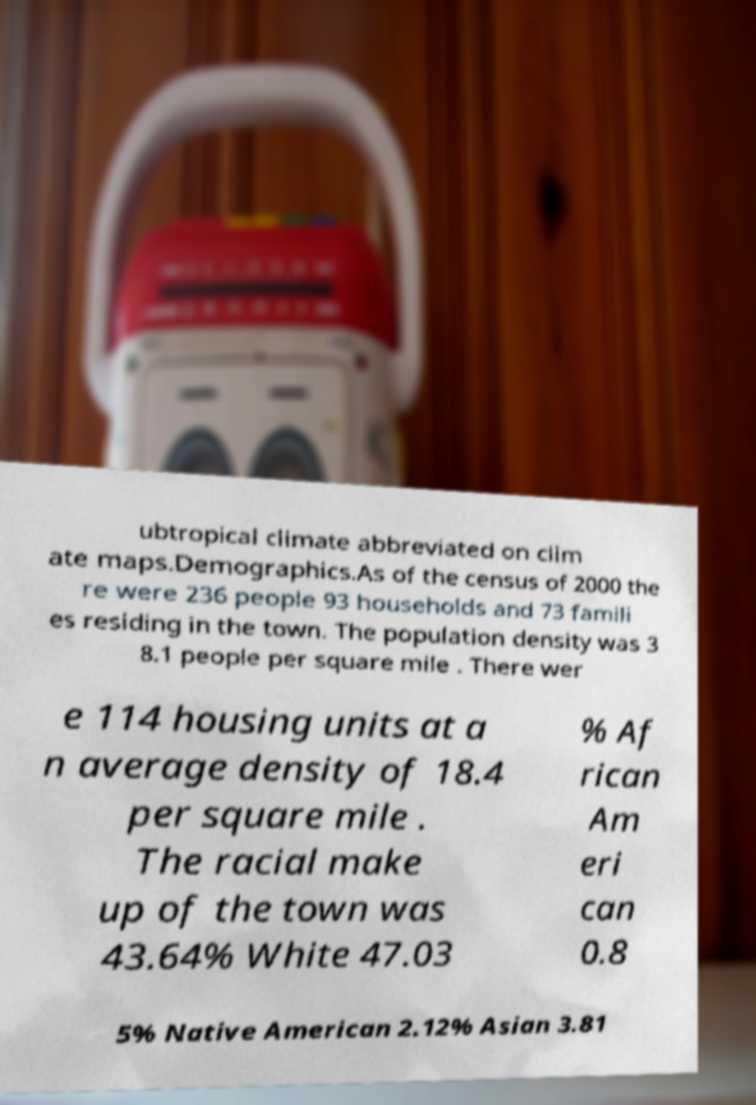I need the written content from this picture converted into text. Can you do that? ubtropical climate abbreviated on clim ate maps.Demographics.As of the census of 2000 the re were 236 people 93 households and 73 famili es residing in the town. The population density was 3 8.1 people per square mile . There wer e 114 housing units at a n average density of 18.4 per square mile . The racial make up of the town was 43.64% White 47.03 % Af rican Am eri can 0.8 5% Native American 2.12% Asian 3.81 